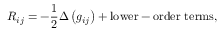Convert formula to latex. <formula><loc_0><loc_0><loc_500><loc_500>R _ { i j } = - { \frac { 1 } { 2 } } \Delta \left ( g _ { i j } \right ) + { l o w e r - o r d e r t e r m s } ,</formula> 